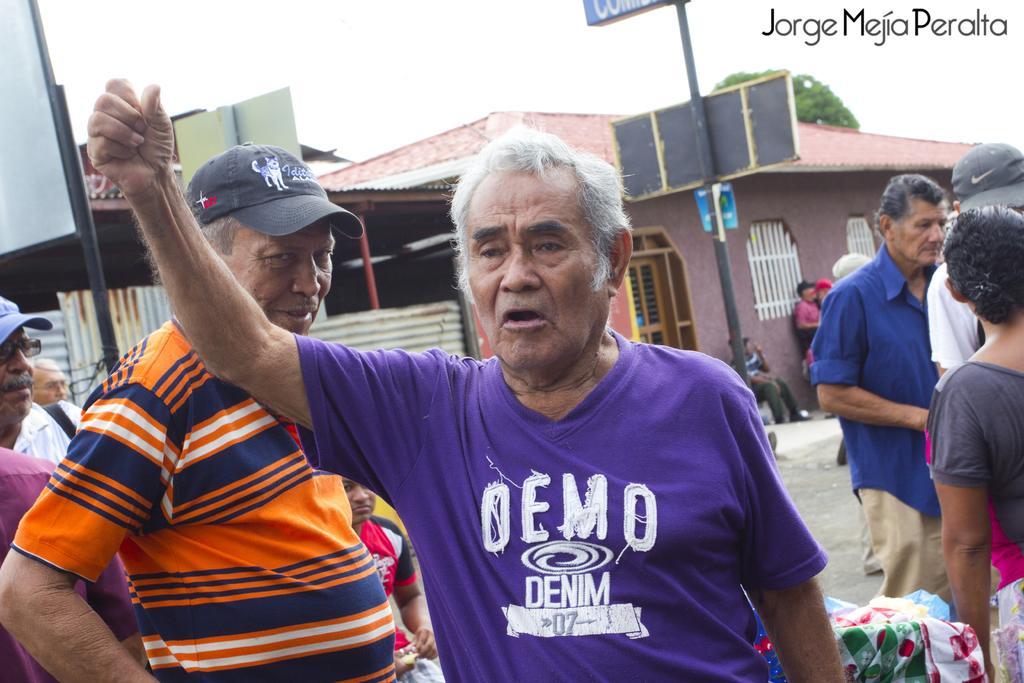Can you describe this image briefly? In this image I can see few persons standing, few clothes, few poles, few boards, few buildings and a tree which is green in color. In the background I can see the sky. 